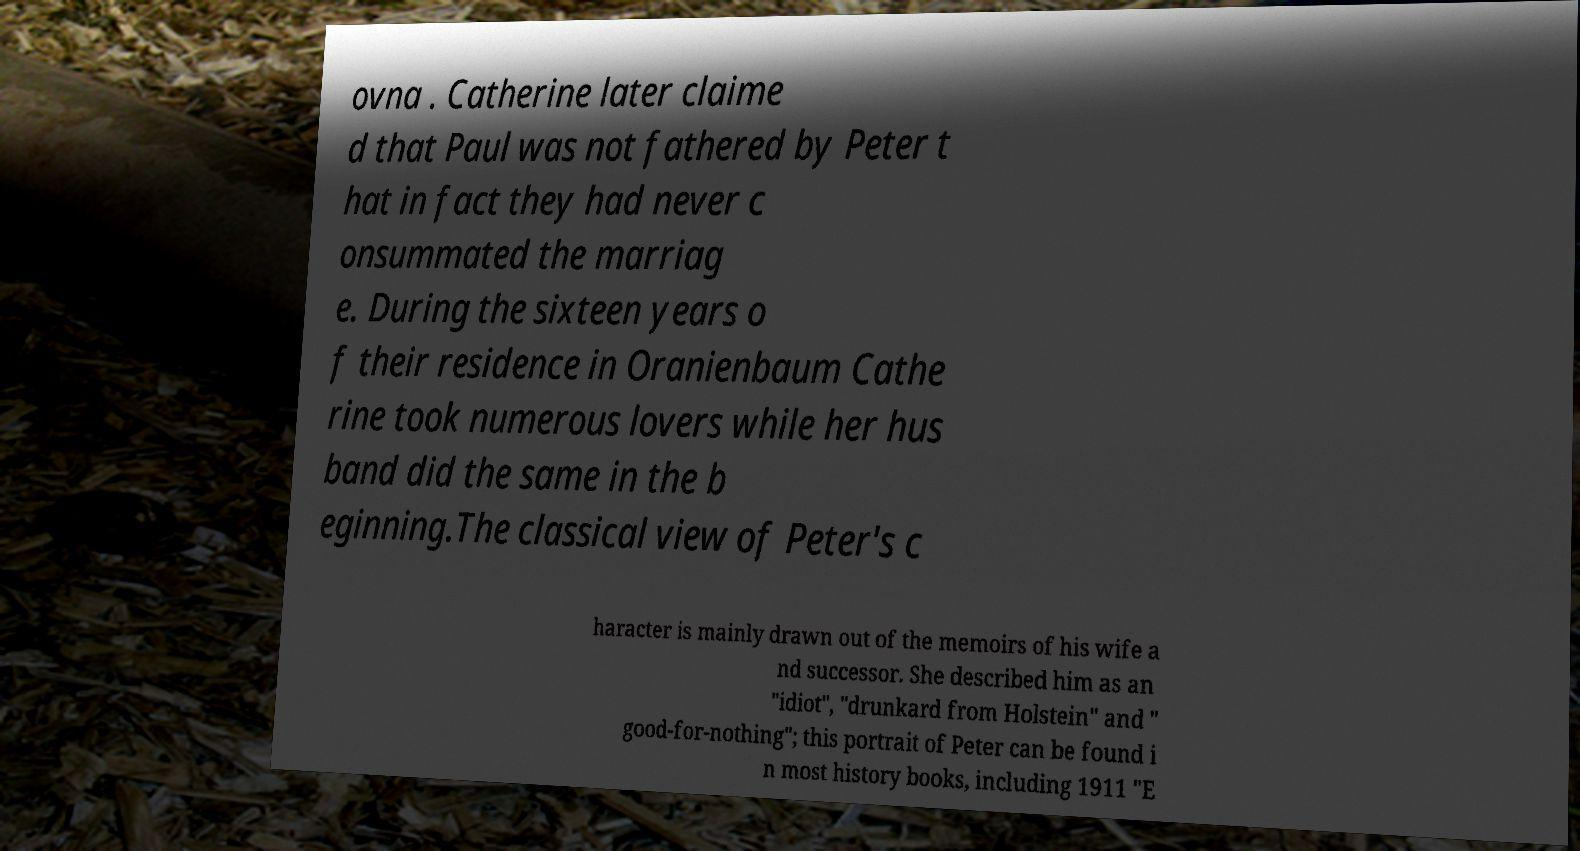Please identify and transcribe the text found in this image. ovna . Catherine later claime d that Paul was not fathered by Peter t hat in fact they had never c onsummated the marriag e. During the sixteen years o f their residence in Oranienbaum Cathe rine took numerous lovers while her hus band did the same in the b eginning.The classical view of Peter's c haracter is mainly drawn out of the memoirs of his wife a nd successor. She described him as an "idiot", "drunkard from Holstein" and " good-for-nothing"; this portrait of Peter can be found i n most history books, including 1911 "E 